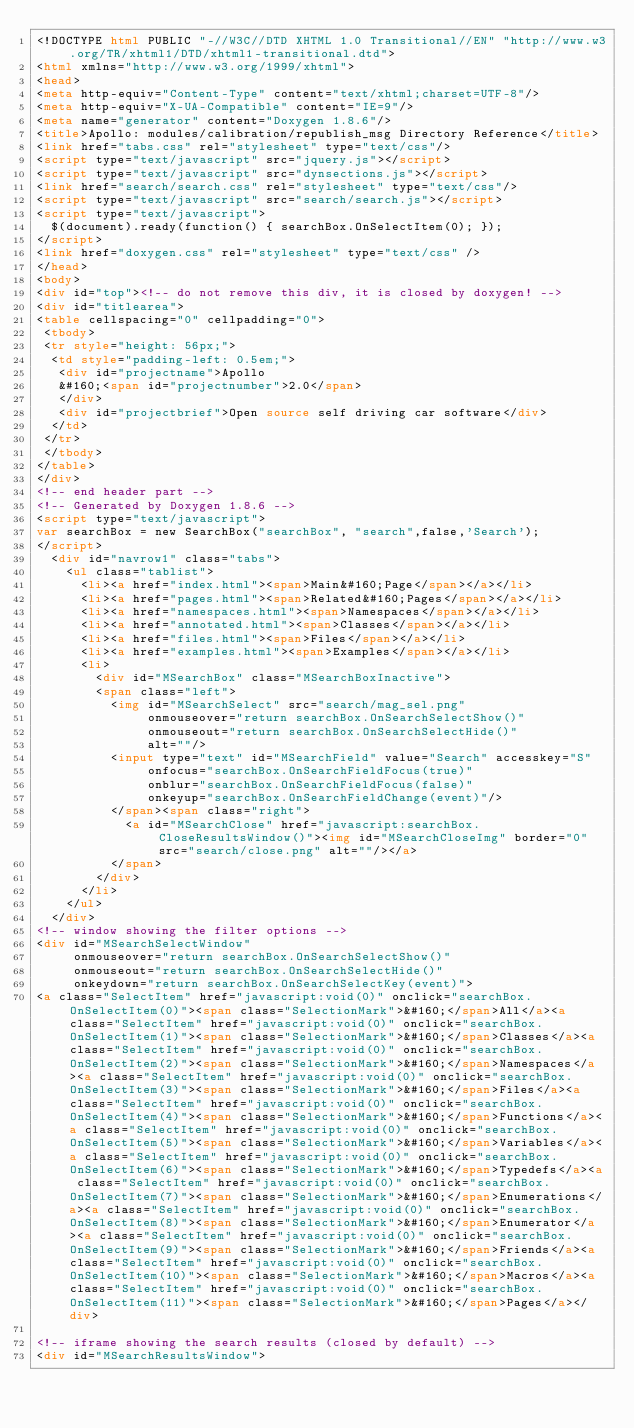<code> <loc_0><loc_0><loc_500><loc_500><_HTML_><!DOCTYPE html PUBLIC "-//W3C//DTD XHTML 1.0 Transitional//EN" "http://www.w3.org/TR/xhtml1/DTD/xhtml1-transitional.dtd">
<html xmlns="http://www.w3.org/1999/xhtml">
<head>
<meta http-equiv="Content-Type" content="text/xhtml;charset=UTF-8"/>
<meta http-equiv="X-UA-Compatible" content="IE=9"/>
<meta name="generator" content="Doxygen 1.8.6"/>
<title>Apollo: modules/calibration/republish_msg Directory Reference</title>
<link href="tabs.css" rel="stylesheet" type="text/css"/>
<script type="text/javascript" src="jquery.js"></script>
<script type="text/javascript" src="dynsections.js"></script>
<link href="search/search.css" rel="stylesheet" type="text/css"/>
<script type="text/javascript" src="search/search.js"></script>
<script type="text/javascript">
  $(document).ready(function() { searchBox.OnSelectItem(0); });
</script>
<link href="doxygen.css" rel="stylesheet" type="text/css" />
</head>
<body>
<div id="top"><!-- do not remove this div, it is closed by doxygen! -->
<div id="titlearea">
<table cellspacing="0" cellpadding="0">
 <tbody>
 <tr style="height: 56px;">
  <td style="padding-left: 0.5em;">
   <div id="projectname">Apollo
   &#160;<span id="projectnumber">2.0</span>
   </div>
   <div id="projectbrief">Open source self driving car software</div>
  </td>
 </tr>
 </tbody>
</table>
</div>
<!-- end header part -->
<!-- Generated by Doxygen 1.8.6 -->
<script type="text/javascript">
var searchBox = new SearchBox("searchBox", "search",false,'Search');
</script>
  <div id="navrow1" class="tabs">
    <ul class="tablist">
      <li><a href="index.html"><span>Main&#160;Page</span></a></li>
      <li><a href="pages.html"><span>Related&#160;Pages</span></a></li>
      <li><a href="namespaces.html"><span>Namespaces</span></a></li>
      <li><a href="annotated.html"><span>Classes</span></a></li>
      <li><a href="files.html"><span>Files</span></a></li>
      <li><a href="examples.html"><span>Examples</span></a></li>
      <li>
        <div id="MSearchBox" class="MSearchBoxInactive">
        <span class="left">
          <img id="MSearchSelect" src="search/mag_sel.png"
               onmouseover="return searchBox.OnSearchSelectShow()"
               onmouseout="return searchBox.OnSearchSelectHide()"
               alt=""/>
          <input type="text" id="MSearchField" value="Search" accesskey="S"
               onfocus="searchBox.OnSearchFieldFocus(true)" 
               onblur="searchBox.OnSearchFieldFocus(false)" 
               onkeyup="searchBox.OnSearchFieldChange(event)"/>
          </span><span class="right">
            <a id="MSearchClose" href="javascript:searchBox.CloseResultsWindow()"><img id="MSearchCloseImg" border="0" src="search/close.png" alt=""/></a>
          </span>
        </div>
      </li>
    </ul>
  </div>
<!-- window showing the filter options -->
<div id="MSearchSelectWindow"
     onmouseover="return searchBox.OnSearchSelectShow()"
     onmouseout="return searchBox.OnSearchSelectHide()"
     onkeydown="return searchBox.OnSearchSelectKey(event)">
<a class="SelectItem" href="javascript:void(0)" onclick="searchBox.OnSelectItem(0)"><span class="SelectionMark">&#160;</span>All</a><a class="SelectItem" href="javascript:void(0)" onclick="searchBox.OnSelectItem(1)"><span class="SelectionMark">&#160;</span>Classes</a><a class="SelectItem" href="javascript:void(0)" onclick="searchBox.OnSelectItem(2)"><span class="SelectionMark">&#160;</span>Namespaces</a><a class="SelectItem" href="javascript:void(0)" onclick="searchBox.OnSelectItem(3)"><span class="SelectionMark">&#160;</span>Files</a><a class="SelectItem" href="javascript:void(0)" onclick="searchBox.OnSelectItem(4)"><span class="SelectionMark">&#160;</span>Functions</a><a class="SelectItem" href="javascript:void(0)" onclick="searchBox.OnSelectItem(5)"><span class="SelectionMark">&#160;</span>Variables</a><a class="SelectItem" href="javascript:void(0)" onclick="searchBox.OnSelectItem(6)"><span class="SelectionMark">&#160;</span>Typedefs</a><a class="SelectItem" href="javascript:void(0)" onclick="searchBox.OnSelectItem(7)"><span class="SelectionMark">&#160;</span>Enumerations</a><a class="SelectItem" href="javascript:void(0)" onclick="searchBox.OnSelectItem(8)"><span class="SelectionMark">&#160;</span>Enumerator</a><a class="SelectItem" href="javascript:void(0)" onclick="searchBox.OnSelectItem(9)"><span class="SelectionMark">&#160;</span>Friends</a><a class="SelectItem" href="javascript:void(0)" onclick="searchBox.OnSelectItem(10)"><span class="SelectionMark">&#160;</span>Macros</a><a class="SelectItem" href="javascript:void(0)" onclick="searchBox.OnSelectItem(11)"><span class="SelectionMark">&#160;</span>Pages</a></div>

<!-- iframe showing the search results (closed by default) -->
<div id="MSearchResultsWindow"></code> 